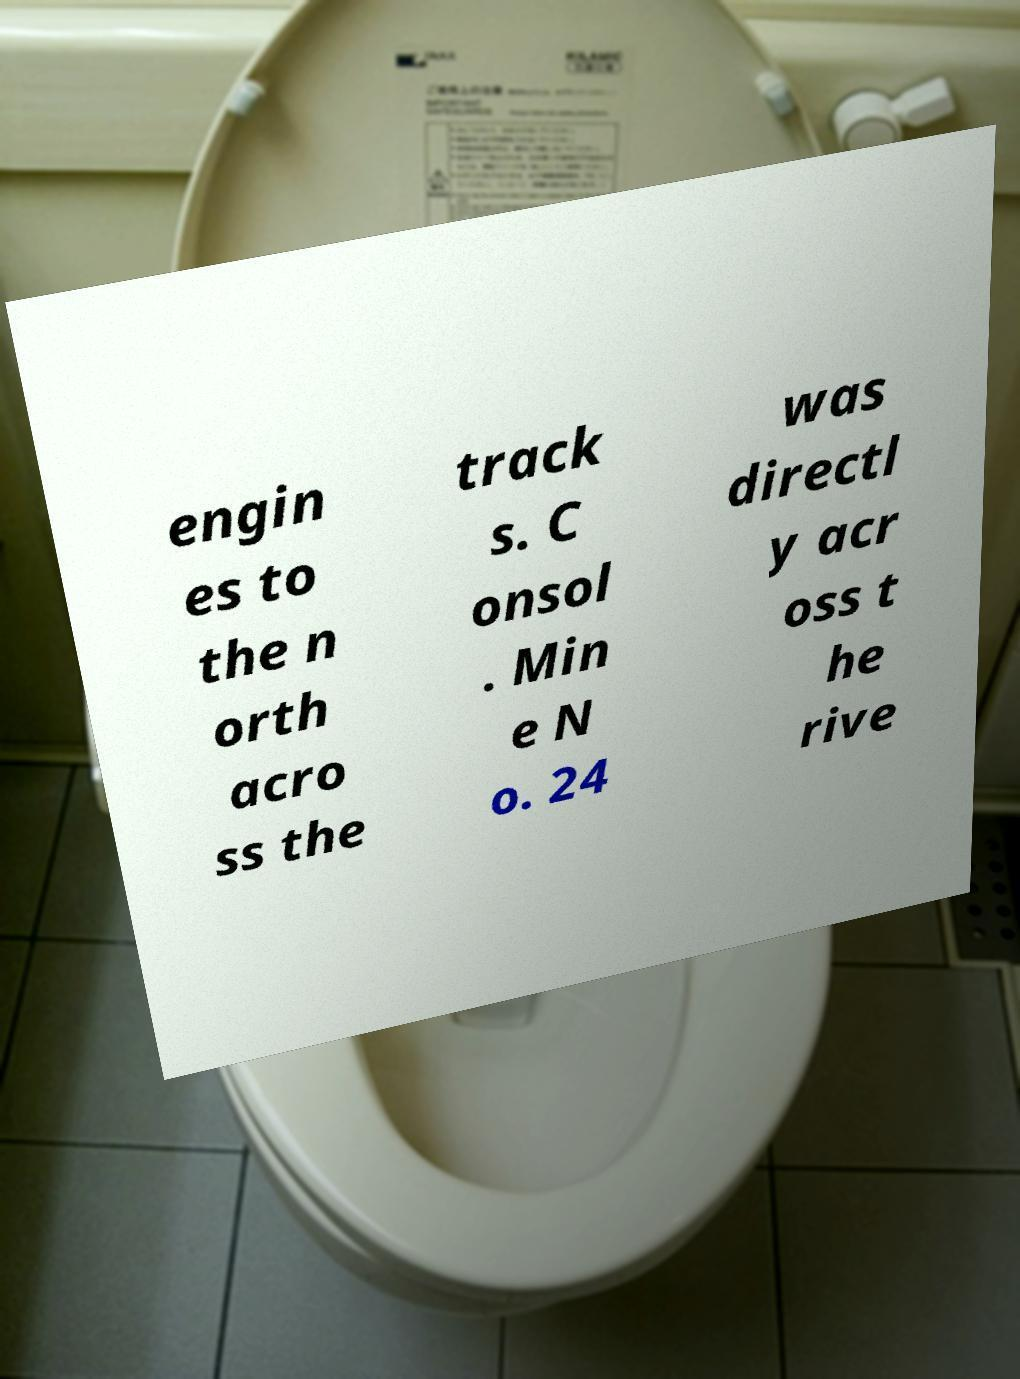I need the written content from this picture converted into text. Can you do that? engin es to the n orth acro ss the track s. C onsol . Min e N o. 24 was directl y acr oss t he rive 